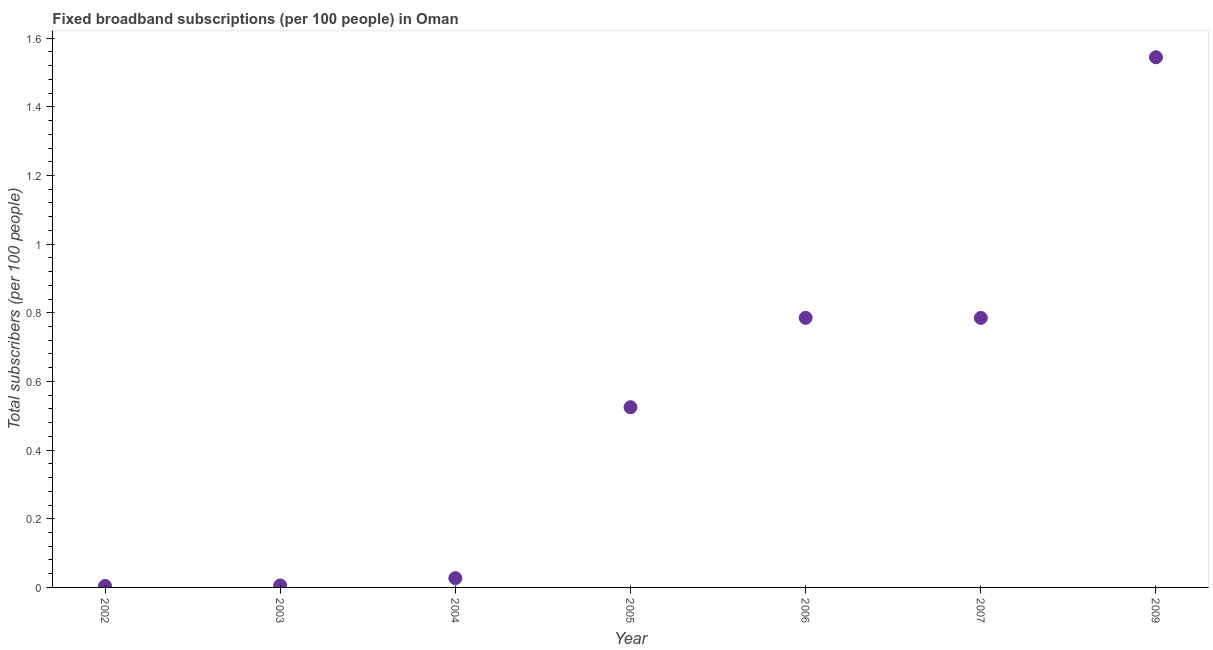What is the total number of fixed broadband subscriptions in 2002?
Offer a very short reply. 0. Across all years, what is the maximum total number of fixed broadband subscriptions?
Give a very brief answer. 1.54. Across all years, what is the minimum total number of fixed broadband subscriptions?
Provide a succinct answer. 0. What is the sum of the total number of fixed broadband subscriptions?
Ensure brevity in your answer.  3.68. What is the difference between the total number of fixed broadband subscriptions in 2007 and 2009?
Provide a short and direct response. -0.76. What is the average total number of fixed broadband subscriptions per year?
Offer a terse response. 0.53. What is the median total number of fixed broadband subscriptions?
Make the answer very short. 0.52. In how many years, is the total number of fixed broadband subscriptions greater than 1.08 ?
Offer a terse response. 1. What is the ratio of the total number of fixed broadband subscriptions in 2005 to that in 2007?
Your response must be concise. 0.67. Is the total number of fixed broadband subscriptions in 2005 less than that in 2009?
Give a very brief answer. Yes. Is the difference between the total number of fixed broadband subscriptions in 2002 and 2003 greater than the difference between any two years?
Your answer should be very brief. No. What is the difference between the highest and the second highest total number of fixed broadband subscriptions?
Your answer should be very brief. 0.76. What is the difference between the highest and the lowest total number of fixed broadband subscriptions?
Your response must be concise. 1.54. In how many years, is the total number of fixed broadband subscriptions greater than the average total number of fixed broadband subscriptions taken over all years?
Ensure brevity in your answer.  3. How many years are there in the graph?
Your answer should be very brief. 7. Does the graph contain grids?
Keep it short and to the point. No. What is the title of the graph?
Provide a succinct answer. Fixed broadband subscriptions (per 100 people) in Oman. What is the label or title of the X-axis?
Ensure brevity in your answer.  Year. What is the label or title of the Y-axis?
Provide a succinct answer. Total subscribers (per 100 people). What is the Total subscribers (per 100 people) in 2002?
Your answer should be compact. 0. What is the Total subscribers (per 100 people) in 2003?
Provide a succinct answer. 0.01. What is the Total subscribers (per 100 people) in 2004?
Give a very brief answer. 0.03. What is the Total subscribers (per 100 people) in 2005?
Keep it short and to the point. 0.52. What is the Total subscribers (per 100 people) in 2006?
Keep it short and to the point. 0.79. What is the Total subscribers (per 100 people) in 2007?
Your answer should be very brief. 0.79. What is the Total subscribers (per 100 people) in 2009?
Offer a very short reply. 1.54. What is the difference between the Total subscribers (per 100 people) in 2002 and 2003?
Make the answer very short. -0. What is the difference between the Total subscribers (per 100 people) in 2002 and 2004?
Offer a very short reply. -0.02. What is the difference between the Total subscribers (per 100 people) in 2002 and 2005?
Offer a very short reply. -0.52. What is the difference between the Total subscribers (per 100 people) in 2002 and 2006?
Your answer should be very brief. -0.78. What is the difference between the Total subscribers (per 100 people) in 2002 and 2007?
Ensure brevity in your answer.  -0.78. What is the difference between the Total subscribers (per 100 people) in 2002 and 2009?
Give a very brief answer. -1.54. What is the difference between the Total subscribers (per 100 people) in 2003 and 2004?
Keep it short and to the point. -0.02. What is the difference between the Total subscribers (per 100 people) in 2003 and 2005?
Give a very brief answer. -0.52. What is the difference between the Total subscribers (per 100 people) in 2003 and 2006?
Ensure brevity in your answer.  -0.78. What is the difference between the Total subscribers (per 100 people) in 2003 and 2007?
Keep it short and to the point. -0.78. What is the difference between the Total subscribers (per 100 people) in 2003 and 2009?
Provide a short and direct response. -1.54. What is the difference between the Total subscribers (per 100 people) in 2004 and 2005?
Keep it short and to the point. -0.5. What is the difference between the Total subscribers (per 100 people) in 2004 and 2006?
Your answer should be compact. -0.76. What is the difference between the Total subscribers (per 100 people) in 2004 and 2007?
Make the answer very short. -0.76. What is the difference between the Total subscribers (per 100 people) in 2004 and 2009?
Make the answer very short. -1.52. What is the difference between the Total subscribers (per 100 people) in 2005 and 2006?
Offer a very short reply. -0.26. What is the difference between the Total subscribers (per 100 people) in 2005 and 2007?
Your answer should be compact. -0.26. What is the difference between the Total subscribers (per 100 people) in 2005 and 2009?
Make the answer very short. -1.02. What is the difference between the Total subscribers (per 100 people) in 2006 and 2007?
Provide a short and direct response. 0. What is the difference between the Total subscribers (per 100 people) in 2006 and 2009?
Make the answer very short. -0.76. What is the difference between the Total subscribers (per 100 people) in 2007 and 2009?
Your answer should be very brief. -0.76. What is the ratio of the Total subscribers (per 100 people) in 2002 to that in 2003?
Offer a very short reply. 0.74. What is the ratio of the Total subscribers (per 100 people) in 2002 to that in 2004?
Make the answer very short. 0.15. What is the ratio of the Total subscribers (per 100 people) in 2002 to that in 2005?
Your answer should be compact. 0.01. What is the ratio of the Total subscribers (per 100 people) in 2002 to that in 2006?
Keep it short and to the point. 0.01. What is the ratio of the Total subscribers (per 100 people) in 2002 to that in 2007?
Provide a short and direct response. 0.01. What is the ratio of the Total subscribers (per 100 people) in 2002 to that in 2009?
Provide a short and direct response. 0. What is the ratio of the Total subscribers (per 100 people) in 2003 to that in 2004?
Your answer should be very brief. 0.21. What is the ratio of the Total subscribers (per 100 people) in 2003 to that in 2005?
Your response must be concise. 0.01. What is the ratio of the Total subscribers (per 100 people) in 2003 to that in 2006?
Offer a very short reply. 0.01. What is the ratio of the Total subscribers (per 100 people) in 2003 to that in 2007?
Make the answer very short. 0.01. What is the ratio of the Total subscribers (per 100 people) in 2003 to that in 2009?
Provide a short and direct response. 0. What is the ratio of the Total subscribers (per 100 people) in 2004 to that in 2005?
Offer a very short reply. 0.05. What is the ratio of the Total subscribers (per 100 people) in 2004 to that in 2006?
Provide a succinct answer. 0.04. What is the ratio of the Total subscribers (per 100 people) in 2004 to that in 2007?
Provide a short and direct response. 0.04. What is the ratio of the Total subscribers (per 100 people) in 2004 to that in 2009?
Your response must be concise. 0.02. What is the ratio of the Total subscribers (per 100 people) in 2005 to that in 2006?
Keep it short and to the point. 0.67. What is the ratio of the Total subscribers (per 100 people) in 2005 to that in 2007?
Your answer should be very brief. 0.67. What is the ratio of the Total subscribers (per 100 people) in 2005 to that in 2009?
Keep it short and to the point. 0.34. What is the ratio of the Total subscribers (per 100 people) in 2006 to that in 2009?
Ensure brevity in your answer.  0.51. What is the ratio of the Total subscribers (per 100 people) in 2007 to that in 2009?
Your answer should be very brief. 0.51. 